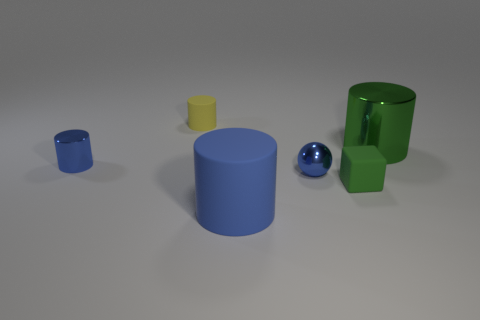Add 1 rubber things. How many objects exist? 7 Subtract all cubes. How many objects are left? 5 Subtract 0 purple cylinders. How many objects are left? 6 Subtract all tiny yellow cylinders. Subtract all blue metal spheres. How many objects are left? 4 Add 6 big matte cylinders. How many big matte cylinders are left? 7 Add 6 small blue balls. How many small blue balls exist? 7 